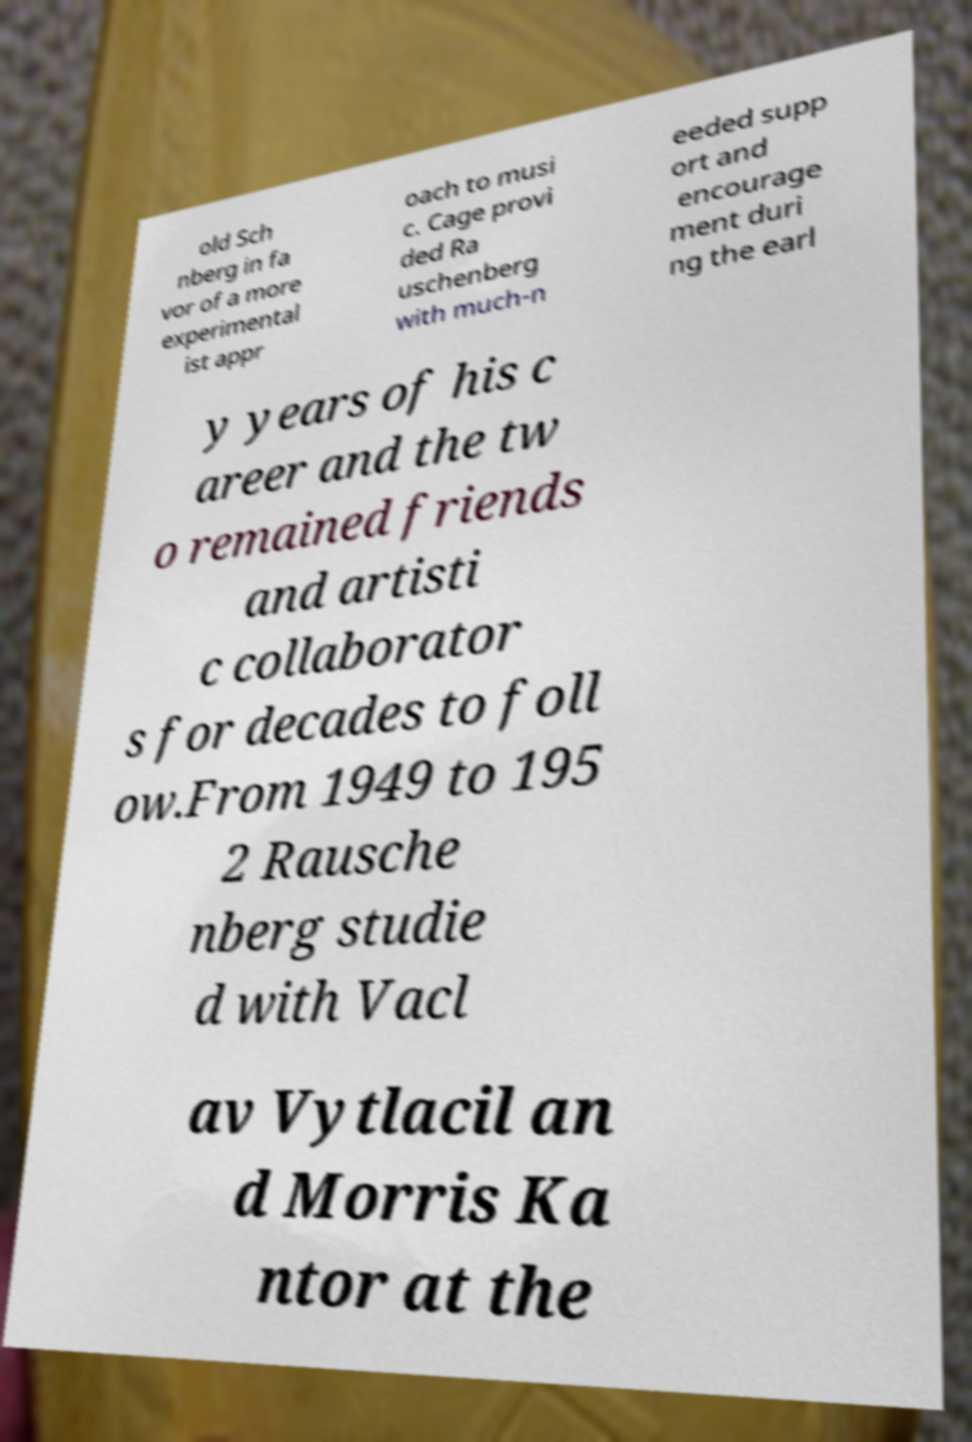There's text embedded in this image that I need extracted. Can you transcribe it verbatim? old Sch nberg in fa vor of a more experimental ist appr oach to musi c. Cage provi ded Ra uschenberg with much-n eeded supp ort and encourage ment duri ng the earl y years of his c areer and the tw o remained friends and artisti c collaborator s for decades to foll ow.From 1949 to 195 2 Rausche nberg studie d with Vacl av Vytlacil an d Morris Ka ntor at the 